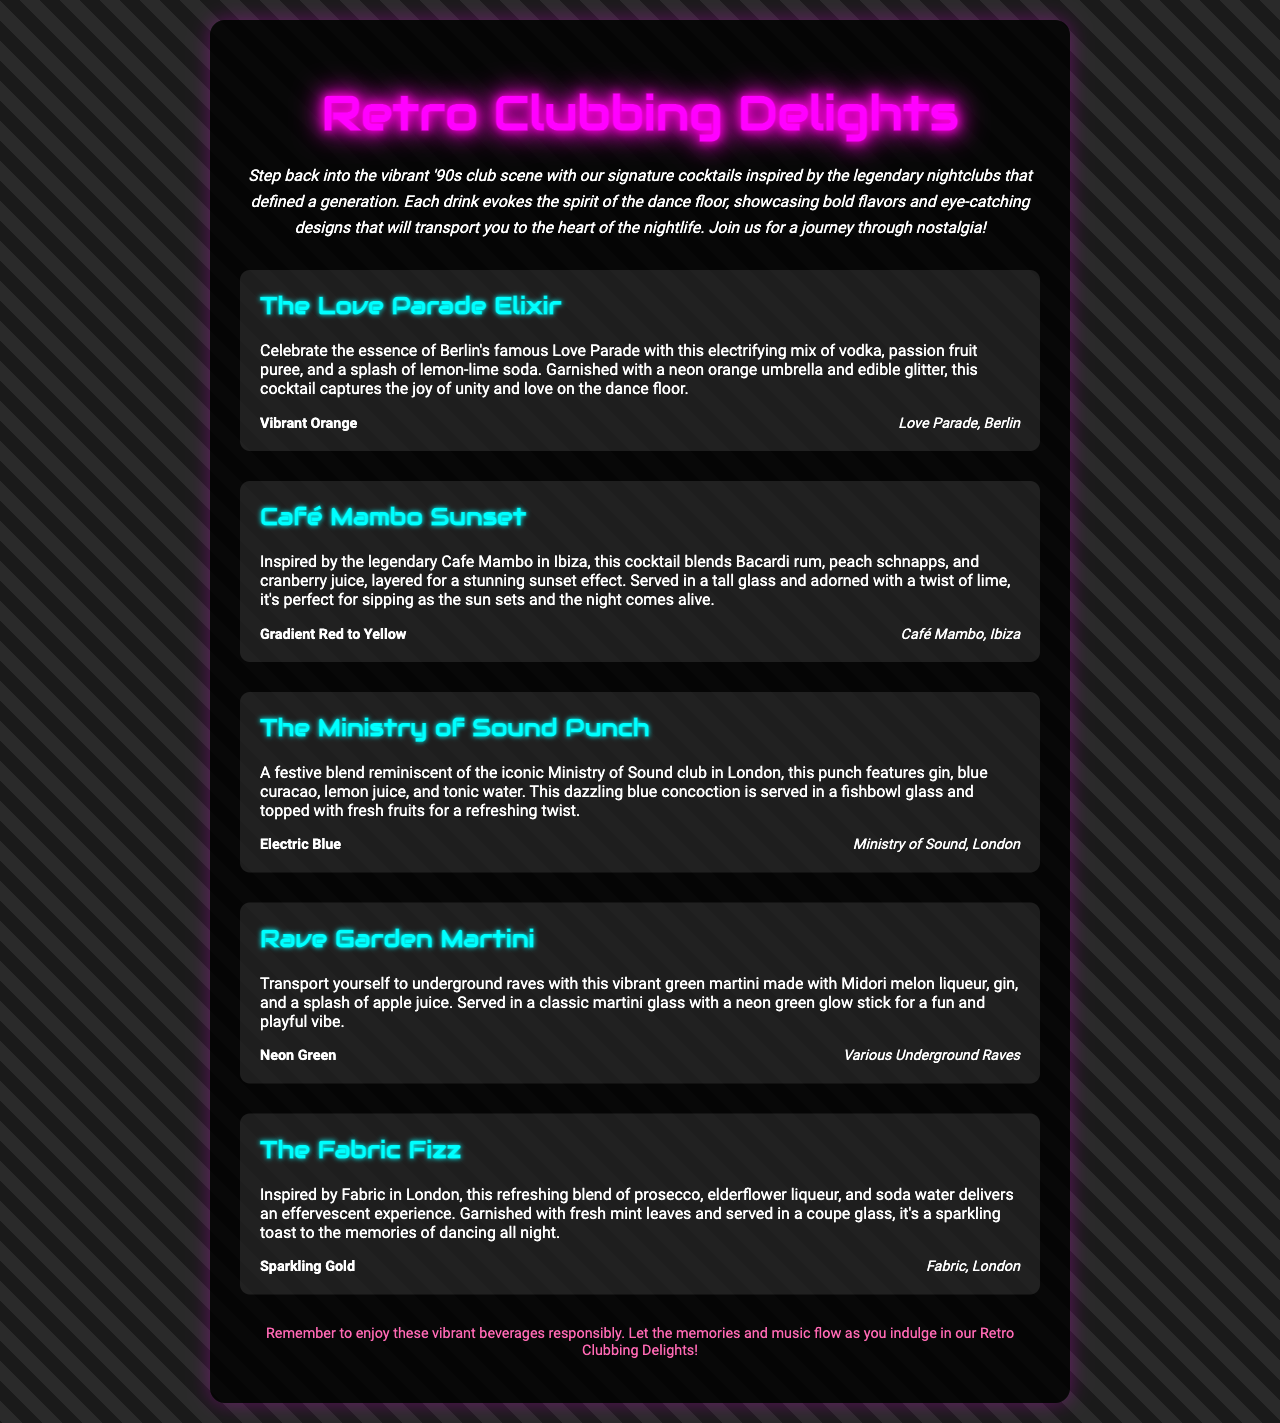What is the name of the cocktail inspired by Berlin's Love Parade? The cocktail inspired by Berlin's Love Parade is mentioned in the document as "The Love Parade Elixir."
Answer: The Love Parade Elixir What color is The Fabric Fizz cocktail? The color of The Fabric Fizz cocktail is specified in the document as "Sparkling Gold."
Answer: Sparkling Gold Which club is associated with the Rave Garden Martini? The Rave Garden Martini is linked to "Various Underground Raves," as noted in the document.
Answer: Various Underground Raves How many cocktails are listed in the menu? The menu provides a total of five distinct cocktail names.
Answer: five What is the key ingredient in the Café Mambo Sunset cocktail? The key ingredients are identified in the document as "Bacardi rum, peach schnapps, and cranberry juice."
Answer: Bacardi rum, peach schnapps, and cranberry juice What type of glass is used for The Love Parade Elixir? The glass type for The Love Parade Elixir is not explicitly mentioned, indicating it is served in a common cocktail glass.
Answer: cocktail glass What is the flavor profile of The Ministry of Sound Punch? The flavor profile includes "gin, blue curacao, lemon juice, and tonic water," as detailed in the cocktail description.
Answer: gin, blue curacao, lemon juice, and tonic water What is the main theme of the cocktail menu? The main theme focuses on cocktails inspired by "the iconic clubs of the '90s."
Answer: iconic clubs of the '90s 